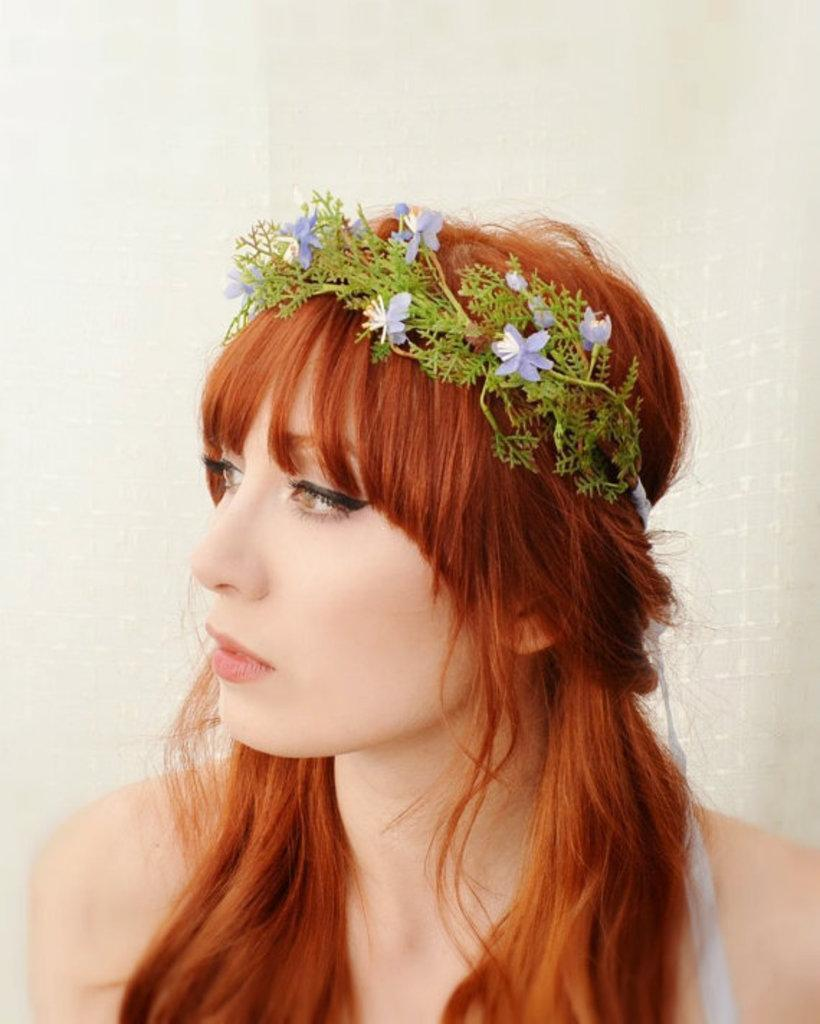Who is the main subject in the image? There is a lady in the image. What is a notable feature of the lady's appearance? The lady has brown hair. What is the lady wearing on her head? The lady is wearing a tiara with flowers and leaves. What can be seen behind the lady in the image? There is a white wall in the background of the image. How many plastic kittens are sitting on the white wall in the image? There are no plastic kittens present in the image; it only features a lady wearing a tiara with flowers and leaves. Is there a bomb visible in the image? No, there is no bomb present in the image. 